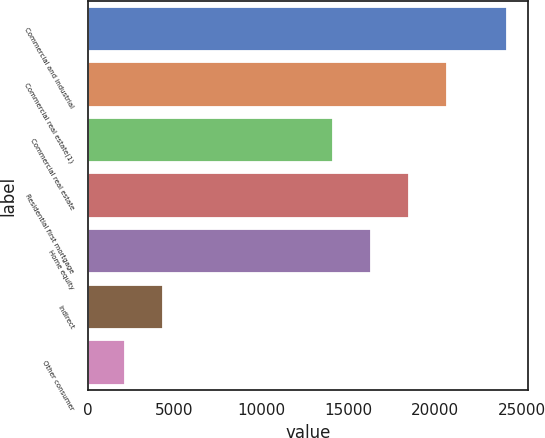Convert chart. <chart><loc_0><loc_0><loc_500><loc_500><bar_chart><fcel>Commercial and industrial<fcel>Commercial real estate(1)<fcel>Commercial real estate<fcel>Residential first mortgage<fcel>Home equity<fcel>Indirect<fcel>Other consumer<nl><fcel>24145<fcel>20726.1<fcel>14121<fcel>18524.4<fcel>16322.7<fcel>4329.7<fcel>2128<nl></chart> 